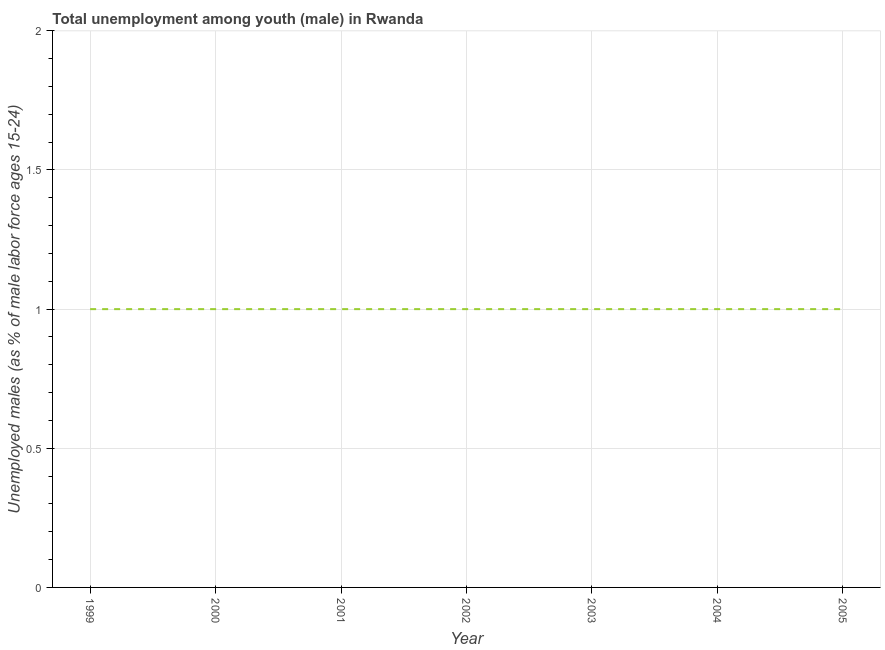What is the unemployed male youth population in 1999?
Your response must be concise. 1. Across all years, what is the maximum unemployed male youth population?
Give a very brief answer. 1. In which year was the unemployed male youth population minimum?
Give a very brief answer. 1999. What is the difference between the unemployed male youth population in 2000 and 2002?
Your answer should be very brief. 0. In how many years, is the unemployed male youth population greater than 1.2 %?
Ensure brevity in your answer.  0. Is the unemployed male youth population in 2001 less than that in 2002?
Your answer should be very brief. No. What is the difference between the highest and the second highest unemployed male youth population?
Your response must be concise. 0. Is the sum of the unemployed male youth population in 2003 and 2004 greater than the maximum unemployed male youth population across all years?
Your response must be concise. Yes. Does the unemployed male youth population monotonically increase over the years?
Provide a short and direct response. No. How many years are there in the graph?
Ensure brevity in your answer.  7. What is the title of the graph?
Offer a very short reply. Total unemployment among youth (male) in Rwanda. What is the label or title of the X-axis?
Give a very brief answer. Year. What is the label or title of the Y-axis?
Provide a succinct answer. Unemployed males (as % of male labor force ages 15-24). What is the Unemployed males (as % of male labor force ages 15-24) in 2000?
Provide a short and direct response. 1. What is the Unemployed males (as % of male labor force ages 15-24) in 2001?
Your answer should be very brief. 1. What is the Unemployed males (as % of male labor force ages 15-24) of 2003?
Provide a succinct answer. 1. What is the Unemployed males (as % of male labor force ages 15-24) of 2004?
Provide a succinct answer. 1. What is the Unemployed males (as % of male labor force ages 15-24) of 2005?
Your answer should be very brief. 1. What is the difference between the Unemployed males (as % of male labor force ages 15-24) in 1999 and 2000?
Make the answer very short. 0. What is the difference between the Unemployed males (as % of male labor force ages 15-24) in 1999 and 2001?
Your answer should be very brief. 0. What is the difference between the Unemployed males (as % of male labor force ages 15-24) in 1999 and 2002?
Provide a short and direct response. 0. What is the difference between the Unemployed males (as % of male labor force ages 15-24) in 1999 and 2003?
Give a very brief answer. 0. What is the difference between the Unemployed males (as % of male labor force ages 15-24) in 1999 and 2004?
Provide a short and direct response. 0. What is the difference between the Unemployed males (as % of male labor force ages 15-24) in 2000 and 2002?
Keep it short and to the point. 0. What is the difference between the Unemployed males (as % of male labor force ages 15-24) in 2000 and 2005?
Offer a very short reply. 0. What is the difference between the Unemployed males (as % of male labor force ages 15-24) in 2001 and 2005?
Offer a very short reply. 0. What is the difference between the Unemployed males (as % of male labor force ages 15-24) in 2002 and 2005?
Your answer should be very brief. 0. What is the difference between the Unemployed males (as % of male labor force ages 15-24) in 2003 and 2004?
Offer a terse response. 0. What is the difference between the Unemployed males (as % of male labor force ages 15-24) in 2003 and 2005?
Provide a short and direct response. 0. What is the difference between the Unemployed males (as % of male labor force ages 15-24) in 2004 and 2005?
Offer a terse response. 0. What is the ratio of the Unemployed males (as % of male labor force ages 15-24) in 1999 to that in 2002?
Your response must be concise. 1. What is the ratio of the Unemployed males (as % of male labor force ages 15-24) in 1999 to that in 2005?
Ensure brevity in your answer.  1. What is the ratio of the Unemployed males (as % of male labor force ages 15-24) in 2000 to that in 2003?
Make the answer very short. 1. What is the ratio of the Unemployed males (as % of male labor force ages 15-24) in 2000 to that in 2004?
Offer a very short reply. 1. What is the ratio of the Unemployed males (as % of male labor force ages 15-24) in 2000 to that in 2005?
Make the answer very short. 1. What is the ratio of the Unemployed males (as % of male labor force ages 15-24) in 2001 to that in 2004?
Your answer should be very brief. 1. What is the ratio of the Unemployed males (as % of male labor force ages 15-24) in 2001 to that in 2005?
Your answer should be very brief. 1. What is the ratio of the Unemployed males (as % of male labor force ages 15-24) in 2002 to that in 2005?
Your answer should be compact. 1. 